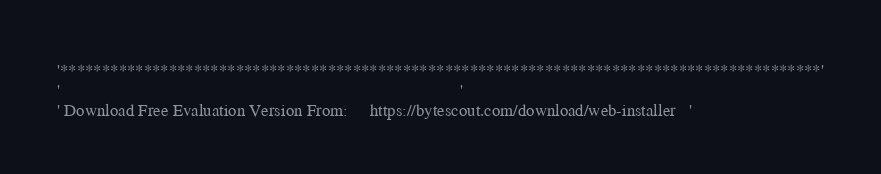<code> <loc_0><loc_0><loc_500><loc_500><_VisualBasic_>'*******************************************************************************************'
'                                                                                           '
' Download Free Evaluation Version From:     https://bytescout.com/download/web-installer   '</code> 